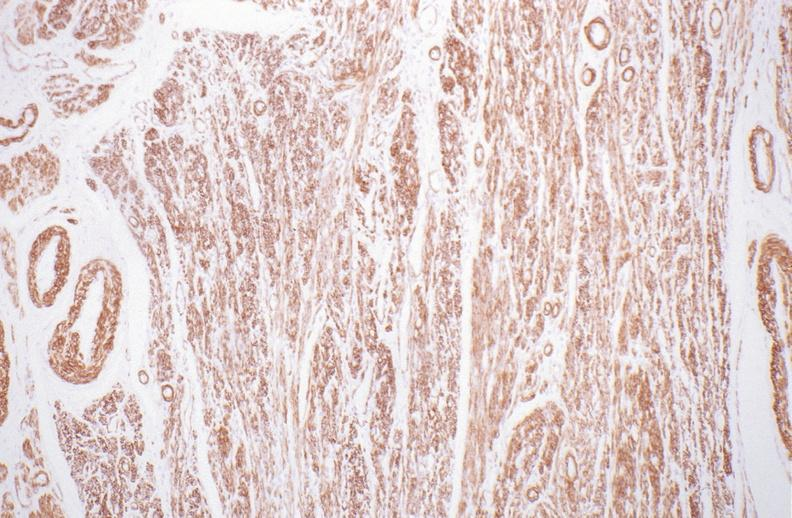s quite good liver present?
Answer the question using a single word or phrase. No 